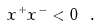<formula> <loc_0><loc_0><loc_500><loc_500>x ^ { + } x ^ { - } < 0 \ .</formula> 